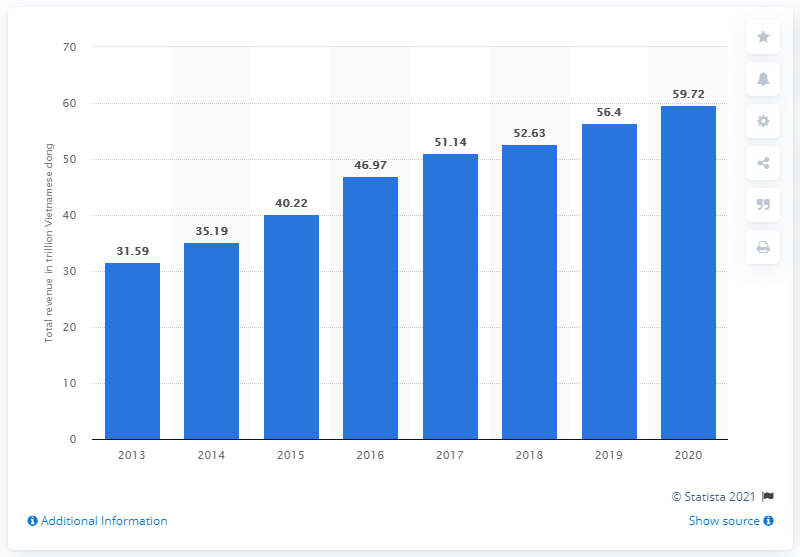Point out several critical features in this image. In the year 2020, Vinamilk generated a total of 59.72 trillion Vietnamese đồng. Vinamilk's total revenue in 2020 was 59.72 billion Vietnamese đồng. 